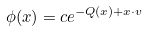Convert formula to latex. <formula><loc_0><loc_0><loc_500><loc_500>\phi ( x ) = c e ^ { - Q ( x ) + x \cdot v }</formula> 